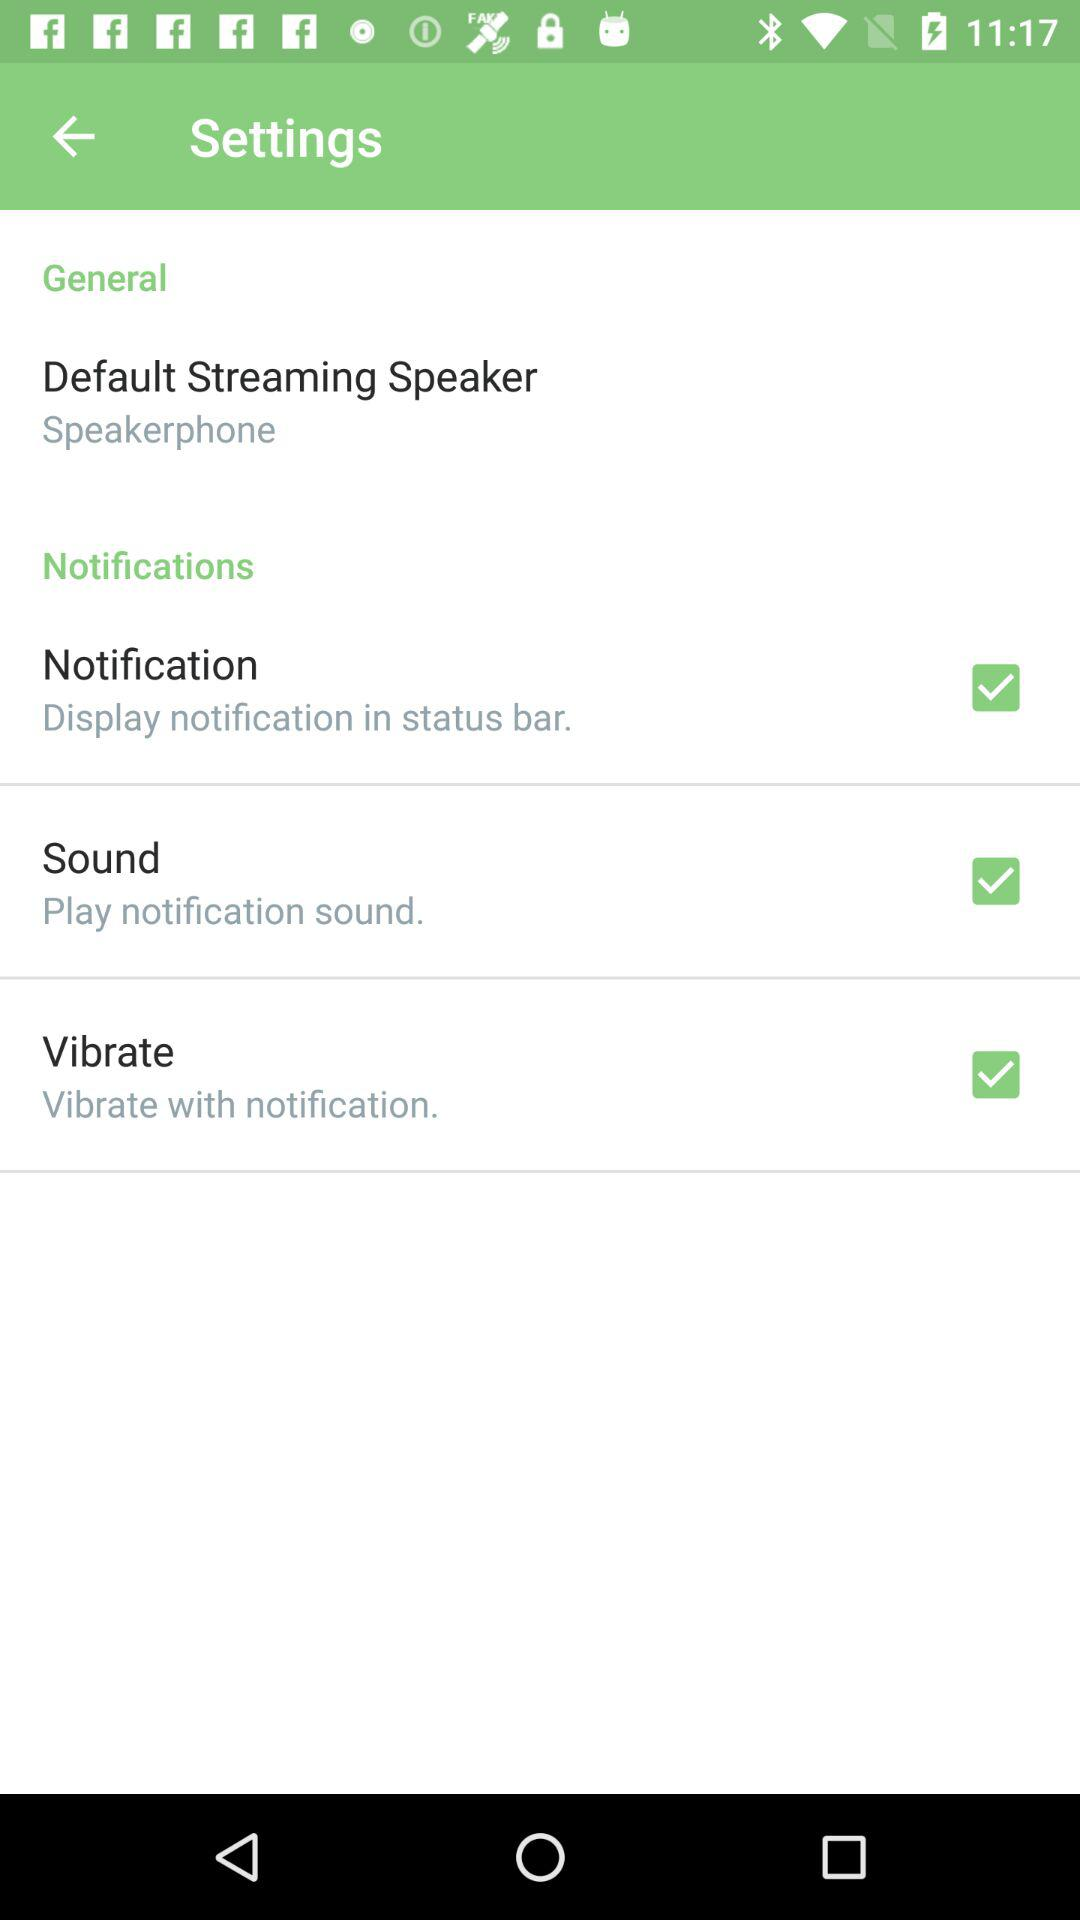What's the status of "Sound"? The status of "Sound" is "on". 